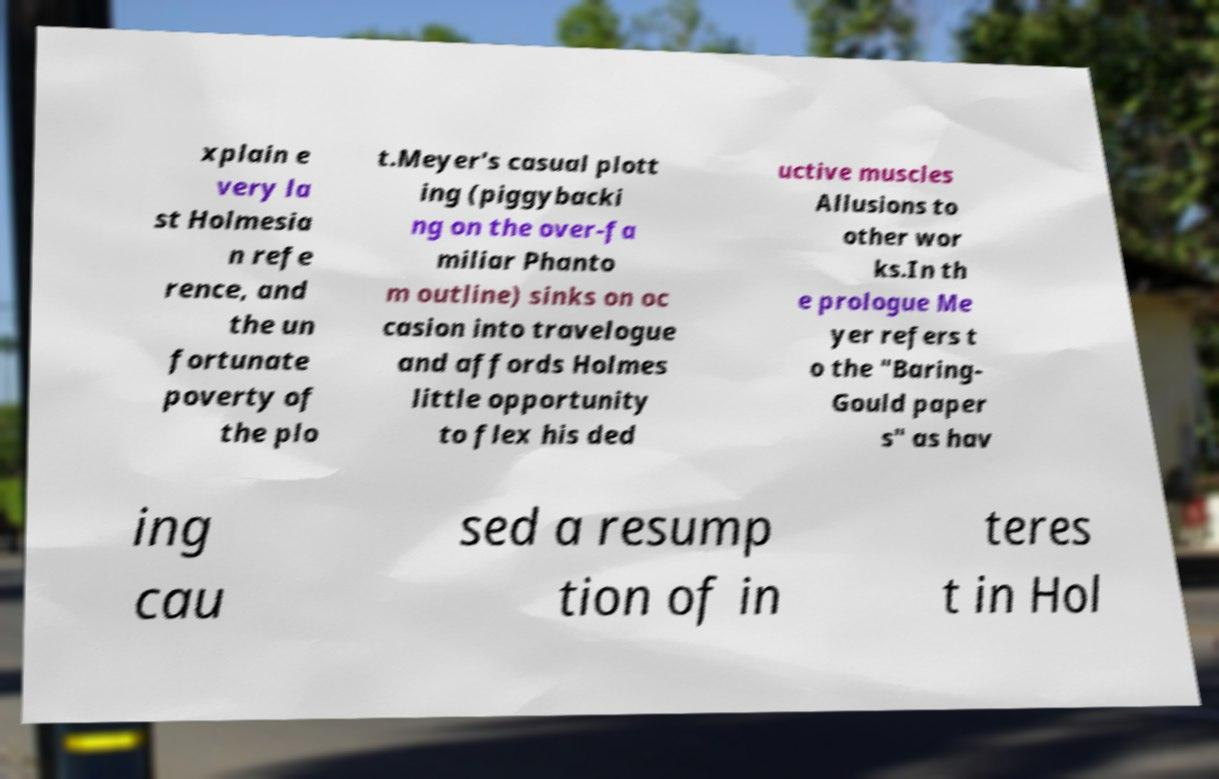Could you extract and type out the text from this image? xplain e very la st Holmesia n refe rence, and the un fortunate poverty of the plo t.Meyer's casual plott ing (piggybacki ng on the over-fa miliar Phanto m outline) sinks on oc casion into travelogue and affords Holmes little opportunity to flex his ded uctive muscles Allusions to other wor ks.In th e prologue Me yer refers t o the "Baring- Gould paper s" as hav ing cau sed a resump tion of in teres t in Hol 